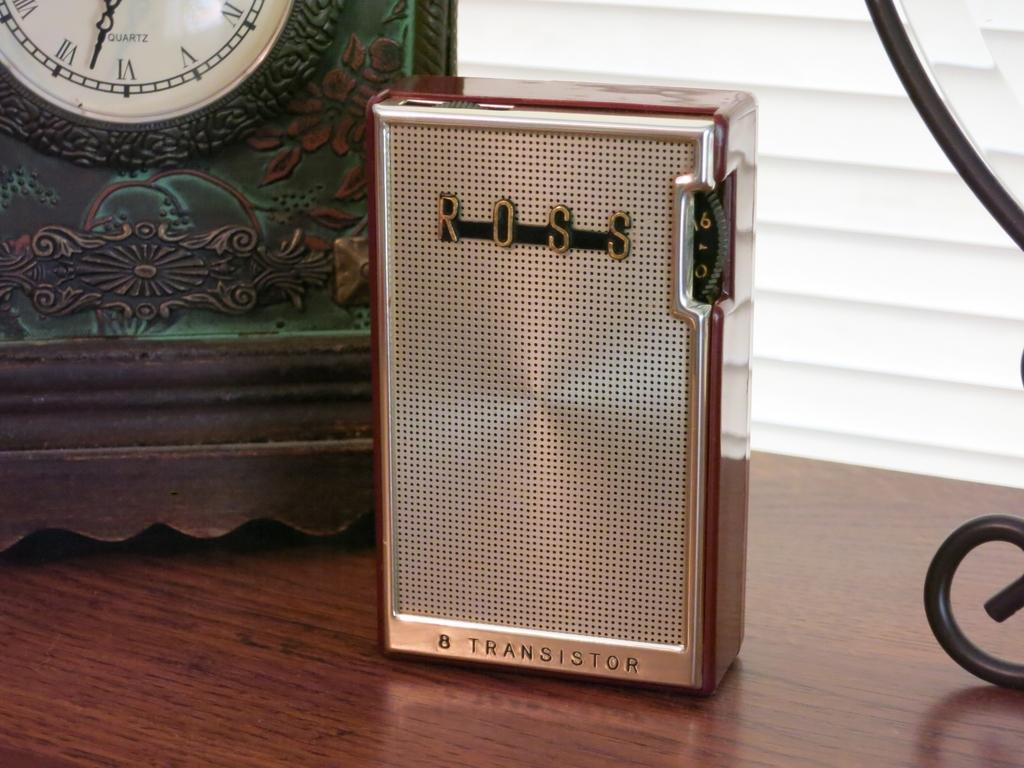<image>
Offer a succinct explanation of the picture presented. The transistor sitting infront of the clock was made by ROSS. 